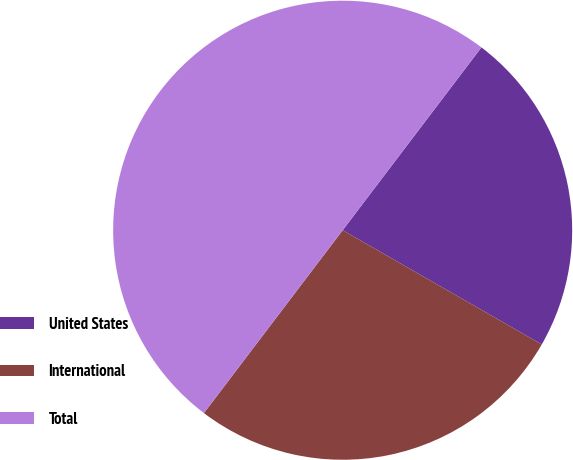<chart> <loc_0><loc_0><loc_500><loc_500><pie_chart><fcel>United States<fcel>International<fcel>Total<nl><fcel>22.96%<fcel>27.04%<fcel>50.0%<nl></chart> 